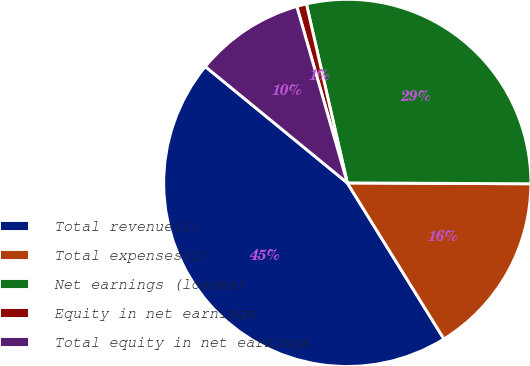Convert chart. <chart><loc_0><loc_0><loc_500><loc_500><pie_chart><fcel>Total revenue(1)<fcel>Total expenses(2)<fcel>Net earnings (losses)<fcel>Equity in net earnings<fcel>Total equity in net earnings<nl><fcel>44.75%<fcel>16.1%<fcel>28.65%<fcel>0.86%<fcel>9.64%<nl></chart> 